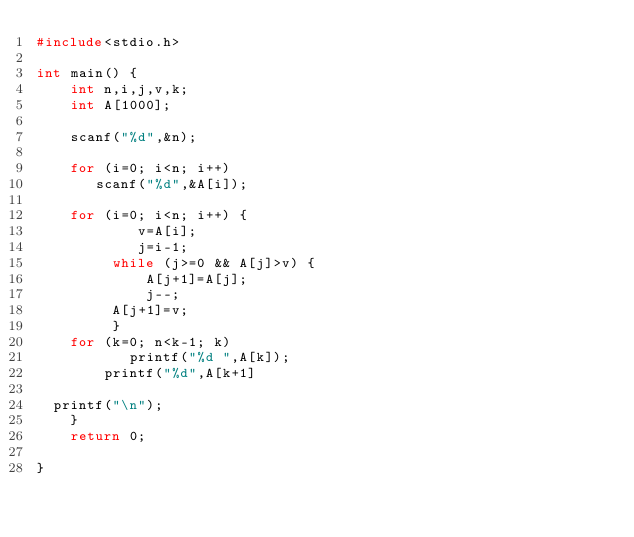<code> <loc_0><loc_0><loc_500><loc_500><_C_>#include<stdio.h>

int main() {
	int n,i,j,v,k;
	int A[1000];

	scanf("%d",&n);

	for (i=0; i<n; i++)
	   scanf("%d",&A[i]);

	for (i=0; i<n; i++) {
			v=A[i];
			j=i-1;
		 while (j>=0 && A[j]>v) {
			 A[j+1]=A[j];
			 j--;
		 A[j+1]=v;
		 }
	for (k=0; n<k-1; k) 
           printf("%d ",A[k]);
        printf("%d",A[k+1]
        
  printf("\n");
	}
	return 0;

}</code> 